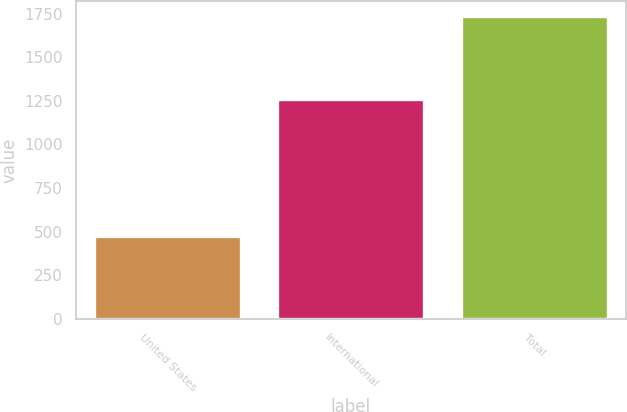Convert chart. <chart><loc_0><loc_0><loc_500><loc_500><bar_chart><fcel>United States<fcel>International<fcel>Total<nl><fcel>475<fcel>1260<fcel>1735<nl></chart> 